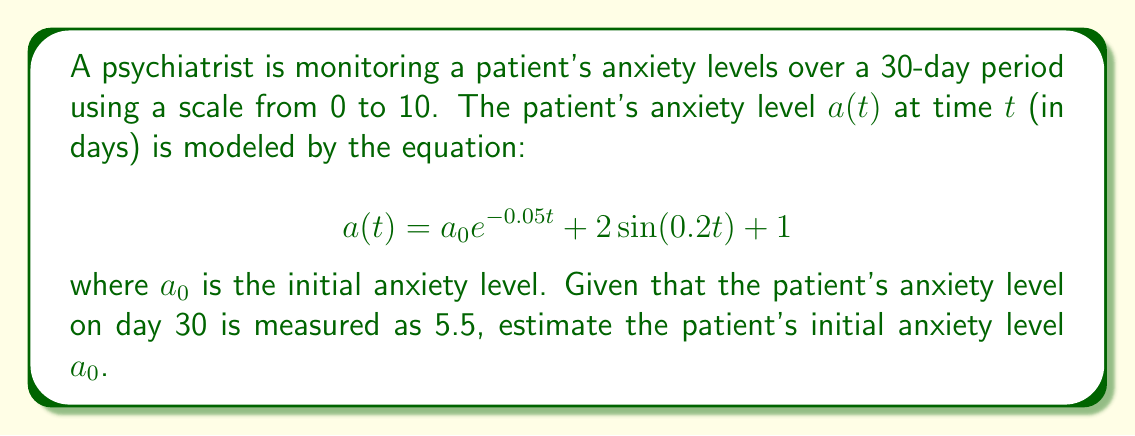Help me with this question. To solve this inverse problem, we need to work backwards from the given information:

1) We know that on day 30, $a(30) = 5.5$. Let's substitute this into our equation:

   $$5.5 = a_0 e^{-0.05(30)} + 2\sin(0.2(30)) + 1$$

2) Simplify the exponential and sine terms:
   
   $$5.5 = a_0 e^{-1.5} + 2\sin(6) + 1$$

3) Calculate the values:
   
   $e^{-1.5} \approx 0.2231$
   $\sin(6) \approx -0.2794$

4) Substitute these values:

   $$5.5 = 0.2231a_0 - 0.5588 + 1$$

5) Simplify:

   $$5.0588 = 0.2231a_0$$

6) Solve for $a_0$:

   $$a_0 = \frac{5.0588}{0.2231} \approx 22.67$$

Therefore, the estimated initial anxiety level is approximately 22.67.
Answer: $a_0 \approx 22.67$ 